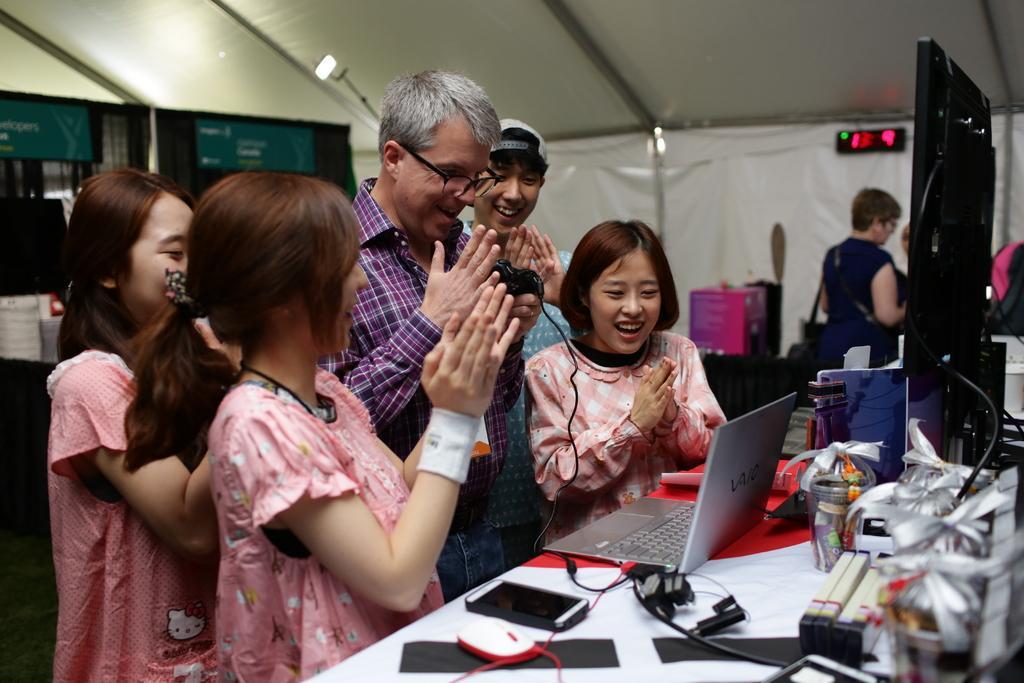How would you summarize this image in a sentence or two? In this picture we can see some people are standing in front of a table, there is a laptop, a mobile phone, a mouse, a monitor, a wire, ribbons and some things present on the table, in the background we can see a digital display and another person, on the left side there are two boards. 